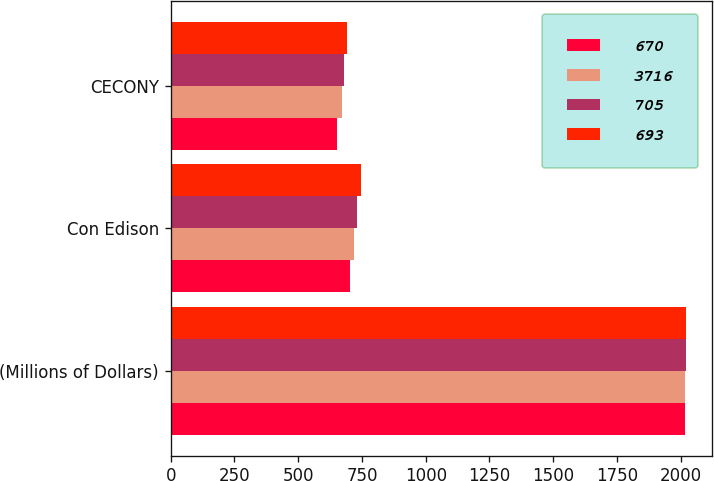<chart> <loc_0><loc_0><loc_500><loc_500><stacked_bar_chart><ecel><fcel>(Millions of Dollars)<fcel>Con Edison<fcel>CECONY<nl><fcel>670<fcel>2017<fcel>702<fcel>653<nl><fcel>3716<fcel>2018<fcel>719<fcel>670<nl><fcel>705<fcel>2019<fcel>730<fcel>679<nl><fcel>693<fcel>2020<fcel>745<fcel>693<nl></chart> 